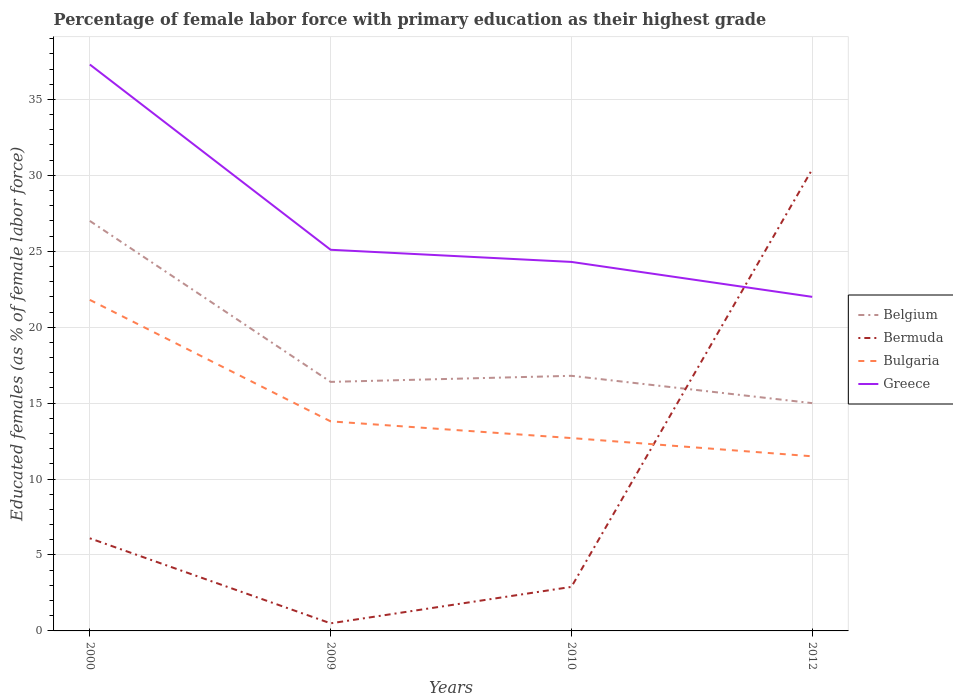Across all years, what is the maximum percentage of female labor force with primary education in Greece?
Ensure brevity in your answer.  22. What is the total percentage of female labor force with primary education in Bulgaria in the graph?
Offer a terse response. 1.1. What is the difference between the highest and the second highest percentage of female labor force with primary education in Greece?
Give a very brief answer. 15.3. What is the difference between the highest and the lowest percentage of female labor force with primary education in Bulgaria?
Offer a very short reply. 1. Is the percentage of female labor force with primary education in Bulgaria strictly greater than the percentage of female labor force with primary education in Belgium over the years?
Provide a succinct answer. Yes. How many lines are there?
Offer a very short reply. 4. How many years are there in the graph?
Offer a very short reply. 4. What is the difference between two consecutive major ticks on the Y-axis?
Ensure brevity in your answer.  5. Are the values on the major ticks of Y-axis written in scientific E-notation?
Your answer should be compact. No. Where does the legend appear in the graph?
Provide a short and direct response. Center right. How many legend labels are there?
Provide a short and direct response. 4. What is the title of the graph?
Give a very brief answer. Percentage of female labor force with primary education as their highest grade. What is the label or title of the X-axis?
Provide a short and direct response. Years. What is the label or title of the Y-axis?
Give a very brief answer. Educated females (as % of female labor force). What is the Educated females (as % of female labor force) in Belgium in 2000?
Your response must be concise. 27. What is the Educated females (as % of female labor force) of Bermuda in 2000?
Provide a short and direct response. 6.1. What is the Educated females (as % of female labor force) of Bulgaria in 2000?
Offer a terse response. 21.8. What is the Educated females (as % of female labor force) in Greece in 2000?
Provide a short and direct response. 37.3. What is the Educated females (as % of female labor force) of Belgium in 2009?
Provide a short and direct response. 16.4. What is the Educated females (as % of female labor force) in Bermuda in 2009?
Make the answer very short. 0.5. What is the Educated females (as % of female labor force) of Bulgaria in 2009?
Offer a terse response. 13.8. What is the Educated females (as % of female labor force) in Greece in 2009?
Give a very brief answer. 25.1. What is the Educated females (as % of female labor force) of Belgium in 2010?
Keep it short and to the point. 16.8. What is the Educated females (as % of female labor force) of Bermuda in 2010?
Provide a succinct answer. 2.9. What is the Educated females (as % of female labor force) of Bulgaria in 2010?
Your answer should be compact. 12.7. What is the Educated females (as % of female labor force) of Greece in 2010?
Your answer should be compact. 24.3. What is the Educated females (as % of female labor force) in Bermuda in 2012?
Provide a succinct answer. 30.4. What is the Educated females (as % of female labor force) of Bulgaria in 2012?
Provide a short and direct response. 11.5. What is the Educated females (as % of female labor force) in Greece in 2012?
Make the answer very short. 22. Across all years, what is the maximum Educated females (as % of female labor force) of Bermuda?
Ensure brevity in your answer.  30.4. Across all years, what is the maximum Educated females (as % of female labor force) of Bulgaria?
Provide a succinct answer. 21.8. Across all years, what is the maximum Educated females (as % of female labor force) in Greece?
Provide a succinct answer. 37.3. Across all years, what is the minimum Educated females (as % of female labor force) in Belgium?
Your answer should be compact. 15. What is the total Educated females (as % of female labor force) in Belgium in the graph?
Your answer should be compact. 75.2. What is the total Educated females (as % of female labor force) of Bermuda in the graph?
Keep it short and to the point. 39.9. What is the total Educated females (as % of female labor force) of Bulgaria in the graph?
Ensure brevity in your answer.  59.8. What is the total Educated females (as % of female labor force) of Greece in the graph?
Keep it short and to the point. 108.7. What is the difference between the Educated females (as % of female labor force) of Bulgaria in 2000 and that in 2009?
Offer a very short reply. 8. What is the difference between the Educated females (as % of female labor force) in Belgium in 2000 and that in 2010?
Give a very brief answer. 10.2. What is the difference between the Educated females (as % of female labor force) of Greece in 2000 and that in 2010?
Your response must be concise. 13. What is the difference between the Educated females (as % of female labor force) of Belgium in 2000 and that in 2012?
Offer a very short reply. 12. What is the difference between the Educated females (as % of female labor force) of Bermuda in 2000 and that in 2012?
Your answer should be compact. -24.3. What is the difference between the Educated females (as % of female labor force) in Bulgaria in 2000 and that in 2012?
Offer a very short reply. 10.3. What is the difference between the Educated females (as % of female labor force) of Bulgaria in 2009 and that in 2010?
Provide a short and direct response. 1.1. What is the difference between the Educated females (as % of female labor force) of Belgium in 2009 and that in 2012?
Your answer should be compact. 1.4. What is the difference between the Educated females (as % of female labor force) of Bermuda in 2009 and that in 2012?
Ensure brevity in your answer.  -29.9. What is the difference between the Educated females (as % of female labor force) in Belgium in 2010 and that in 2012?
Provide a succinct answer. 1.8. What is the difference between the Educated females (as % of female labor force) in Bermuda in 2010 and that in 2012?
Your answer should be very brief. -27.5. What is the difference between the Educated females (as % of female labor force) in Bulgaria in 2010 and that in 2012?
Make the answer very short. 1.2. What is the difference between the Educated females (as % of female labor force) in Belgium in 2000 and the Educated females (as % of female labor force) in Bulgaria in 2009?
Offer a very short reply. 13.2. What is the difference between the Educated females (as % of female labor force) of Bermuda in 2000 and the Educated females (as % of female labor force) of Bulgaria in 2009?
Keep it short and to the point. -7.7. What is the difference between the Educated females (as % of female labor force) in Belgium in 2000 and the Educated females (as % of female labor force) in Bermuda in 2010?
Offer a very short reply. 24.1. What is the difference between the Educated females (as % of female labor force) in Belgium in 2000 and the Educated females (as % of female labor force) in Bulgaria in 2010?
Your answer should be very brief. 14.3. What is the difference between the Educated females (as % of female labor force) of Belgium in 2000 and the Educated females (as % of female labor force) of Greece in 2010?
Provide a succinct answer. 2.7. What is the difference between the Educated females (as % of female labor force) of Bermuda in 2000 and the Educated females (as % of female labor force) of Bulgaria in 2010?
Offer a terse response. -6.6. What is the difference between the Educated females (as % of female labor force) in Bermuda in 2000 and the Educated females (as % of female labor force) in Greece in 2010?
Keep it short and to the point. -18.2. What is the difference between the Educated females (as % of female labor force) of Bulgaria in 2000 and the Educated females (as % of female labor force) of Greece in 2010?
Offer a very short reply. -2.5. What is the difference between the Educated females (as % of female labor force) in Belgium in 2000 and the Educated females (as % of female labor force) in Bermuda in 2012?
Your answer should be compact. -3.4. What is the difference between the Educated females (as % of female labor force) of Belgium in 2000 and the Educated females (as % of female labor force) of Bulgaria in 2012?
Ensure brevity in your answer.  15.5. What is the difference between the Educated females (as % of female labor force) in Bermuda in 2000 and the Educated females (as % of female labor force) in Bulgaria in 2012?
Your answer should be very brief. -5.4. What is the difference between the Educated females (as % of female labor force) of Bermuda in 2000 and the Educated females (as % of female labor force) of Greece in 2012?
Offer a very short reply. -15.9. What is the difference between the Educated females (as % of female labor force) in Bulgaria in 2000 and the Educated females (as % of female labor force) in Greece in 2012?
Offer a very short reply. -0.2. What is the difference between the Educated females (as % of female labor force) in Belgium in 2009 and the Educated females (as % of female labor force) in Greece in 2010?
Your answer should be very brief. -7.9. What is the difference between the Educated females (as % of female labor force) of Bermuda in 2009 and the Educated females (as % of female labor force) of Greece in 2010?
Offer a very short reply. -23.8. What is the difference between the Educated females (as % of female labor force) in Bulgaria in 2009 and the Educated females (as % of female labor force) in Greece in 2010?
Your answer should be compact. -10.5. What is the difference between the Educated females (as % of female labor force) in Belgium in 2009 and the Educated females (as % of female labor force) in Bermuda in 2012?
Your answer should be very brief. -14. What is the difference between the Educated females (as % of female labor force) of Belgium in 2009 and the Educated females (as % of female labor force) of Greece in 2012?
Offer a terse response. -5.6. What is the difference between the Educated females (as % of female labor force) of Bermuda in 2009 and the Educated females (as % of female labor force) of Bulgaria in 2012?
Make the answer very short. -11. What is the difference between the Educated females (as % of female labor force) of Bermuda in 2009 and the Educated females (as % of female labor force) of Greece in 2012?
Make the answer very short. -21.5. What is the difference between the Educated females (as % of female labor force) in Bulgaria in 2009 and the Educated females (as % of female labor force) in Greece in 2012?
Your answer should be very brief. -8.2. What is the difference between the Educated females (as % of female labor force) in Bermuda in 2010 and the Educated females (as % of female labor force) in Bulgaria in 2012?
Ensure brevity in your answer.  -8.6. What is the difference between the Educated females (as % of female labor force) of Bermuda in 2010 and the Educated females (as % of female labor force) of Greece in 2012?
Keep it short and to the point. -19.1. What is the average Educated females (as % of female labor force) in Bermuda per year?
Offer a very short reply. 9.97. What is the average Educated females (as % of female labor force) of Bulgaria per year?
Provide a succinct answer. 14.95. What is the average Educated females (as % of female labor force) in Greece per year?
Your answer should be compact. 27.18. In the year 2000, what is the difference between the Educated females (as % of female labor force) in Belgium and Educated females (as % of female labor force) in Bermuda?
Your answer should be very brief. 20.9. In the year 2000, what is the difference between the Educated females (as % of female labor force) in Belgium and Educated females (as % of female labor force) in Bulgaria?
Provide a succinct answer. 5.2. In the year 2000, what is the difference between the Educated females (as % of female labor force) of Belgium and Educated females (as % of female labor force) of Greece?
Keep it short and to the point. -10.3. In the year 2000, what is the difference between the Educated females (as % of female labor force) of Bermuda and Educated females (as % of female labor force) of Bulgaria?
Keep it short and to the point. -15.7. In the year 2000, what is the difference between the Educated females (as % of female labor force) of Bermuda and Educated females (as % of female labor force) of Greece?
Make the answer very short. -31.2. In the year 2000, what is the difference between the Educated females (as % of female labor force) of Bulgaria and Educated females (as % of female labor force) of Greece?
Give a very brief answer. -15.5. In the year 2009, what is the difference between the Educated females (as % of female labor force) in Belgium and Educated females (as % of female labor force) in Bulgaria?
Ensure brevity in your answer.  2.6. In the year 2009, what is the difference between the Educated females (as % of female labor force) of Bermuda and Educated females (as % of female labor force) of Greece?
Offer a terse response. -24.6. In the year 2009, what is the difference between the Educated females (as % of female labor force) in Bulgaria and Educated females (as % of female labor force) in Greece?
Provide a short and direct response. -11.3. In the year 2010, what is the difference between the Educated females (as % of female labor force) in Belgium and Educated females (as % of female labor force) in Bulgaria?
Offer a terse response. 4.1. In the year 2010, what is the difference between the Educated females (as % of female labor force) of Bermuda and Educated females (as % of female labor force) of Greece?
Your response must be concise. -21.4. In the year 2012, what is the difference between the Educated females (as % of female labor force) in Belgium and Educated females (as % of female labor force) in Bermuda?
Offer a very short reply. -15.4. In the year 2012, what is the difference between the Educated females (as % of female labor force) in Belgium and Educated females (as % of female labor force) in Greece?
Offer a terse response. -7. In the year 2012, what is the difference between the Educated females (as % of female labor force) in Bermuda and Educated females (as % of female labor force) in Bulgaria?
Your answer should be very brief. 18.9. In the year 2012, what is the difference between the Educated females (as % of female labor force) in Bermuda and Educated females (as % of female labor force) in Greece?
Make the answer very short. 8.4. What is the ratio of the Educated females (as % of female labor force) of Belgium in 2000 to that in 2009?
Your answer should be compact. 1.65. What is the ratio of the Educated females (as % of female labor force) in Bulgaria in 2000 to that in 2009?
Keep it short and to the point. 1.58. What is the ratio of the Educated females (as % of female labor force) in Greece in 2000 to that in 2009?
Provide a short and direct response. 1.49. What is the ratio of the Educated females (as % of female labor force) of Belgium in 2000 to that in 2010?
Your response must be concise. 1.61. What is the ratio of the Educated females (as % of female labor force) of Bermuda in 2000 to that in 2010?
Keep it short and to the point. 2.1. What is the ratio of the Educated females (as % of female labor force) in Bulgaria in 2000 to that in 2010?
Provide a succinct answer. 1.72. What is the ratio of the Educated females (as % of female labor force) of Greece in 2000 to that in 2010?
Your response must be concise. 1.53. What is the ratio of the Educated females (as % of female labor force) of Bermuda in 2000 to that in 2012?
Offer a terse response. 0.2. What is the ratio of the Educated females (as % of female labor force) in Bulgaria in 2000 to that in 2012?
Your answer should be very brief. 1.9. What is the ratio of the Educated females (as % of female labor force) of Greece in 2000 to that in 2012?
Provide a short and direct response. 1.7. What is the ratio of the Educated females (as % of female labor force) in Belgium in 2009 to that in 2010?
Keep it short and to the point. 0.98. What is the ratio of the Educated females (as % of female labor force) of Bermuda in 2009 to that in 2010?
Ensure brevity in your answer.  0.17. What is the ratio of the Educated females (as % of female labor force) of Bulgaria in 2009 to that in 2010?
Offer a terse response. 1.09. What is the ratio of the Educated females (as % of female labor force) in Greece in 2009 to that in 2010?
Provide a succinct answer. 1.03. What is the ratio of the Educated females (as % of female labor force) in Belgium in 2009 to that in 2012?
Make the answer very short. 1.09. What is the ratio of the Educated females (as % of female labor force) of Bermuda in 2009 to that in 2012?
Provide a short and direct response. 0.02. What is the ratio of the Educated females (as % of female labor force) of Greece in 2009 to that in 2012?
Give a very brief answer. 1.14. What is the ratio of the Educated females (as % of female labor force) in Belgium in 2010 to that in 2012?
Keep it short and to the point. 1.12. What is the ratio of the Educated females (as % of female labor force) in Bermuda in 2010 to that in 2012?
Ensure brevity in your answer.  0.1. What is the ratio of the Educated females (as % of female labor force) in Bulgaria in 2010 to that in 2012?
Offer a terse response. 1.1. What is the ratio of the Educated females (as % of female labor force) of Greece in 2010 to that in 2012?
Provide a succinct answer. 1.1. What is the difference between the highest and the second highest Educated females (as % of female labor force) in Bermuda?
Provide a succinct answer. 24.3. What is the difference between the highest and the second highest Educated females (as % of female labor force) of Greece?
Your answer should be compact. 12.2. What is the difference between the highest and the lowest Educated females (as % of female labor force) in Belgium?
Your response must be concise. 12. What is the difference between the highest and the lowest Educated females (as % of female labor force) of Bermuda?
Make the answer very short. 29.9. What is the difference between the highest and the lowest Educated females (as % of female labor force) in Greece?
Offer a terse response. 15.3. 